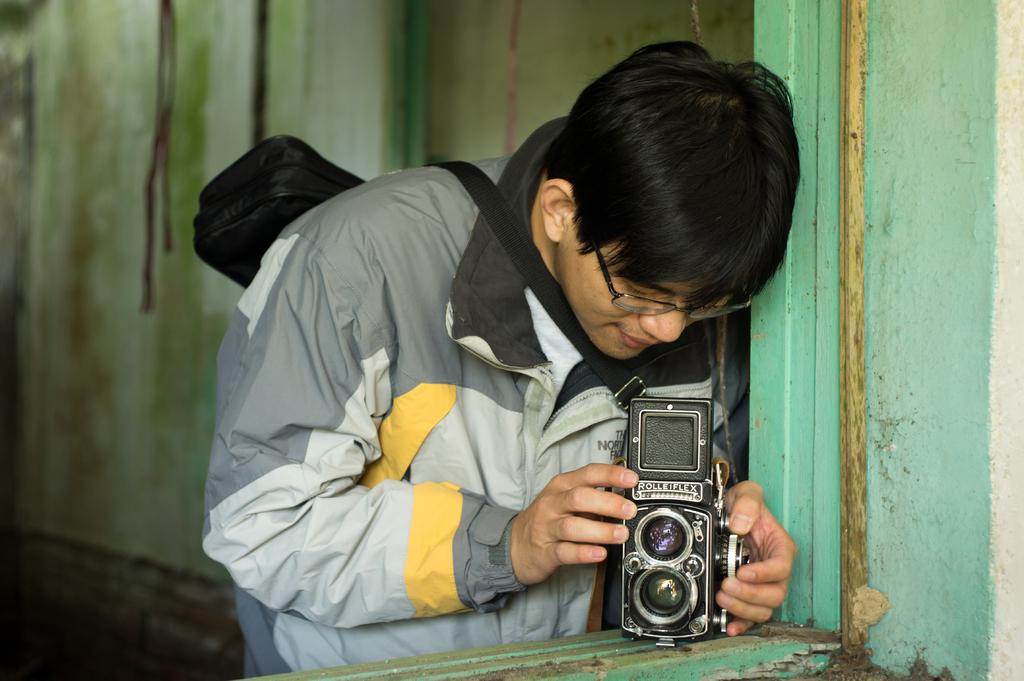Who is the main subject in the image? There is a man in the image. What is the man holding on his back? The man is holding a bag on his back. What is the man holding in his hand? The man is holding a camera in the bottom. What type of eyewear is the man wearing? The man is wearing glasses (specs). What type of clothing is the man wearing on his upper body? The man is wearing a jacket. What type of bean is depicted in the caption of the image? There is no caption present in the image, and therefore no beans can be found in it. 